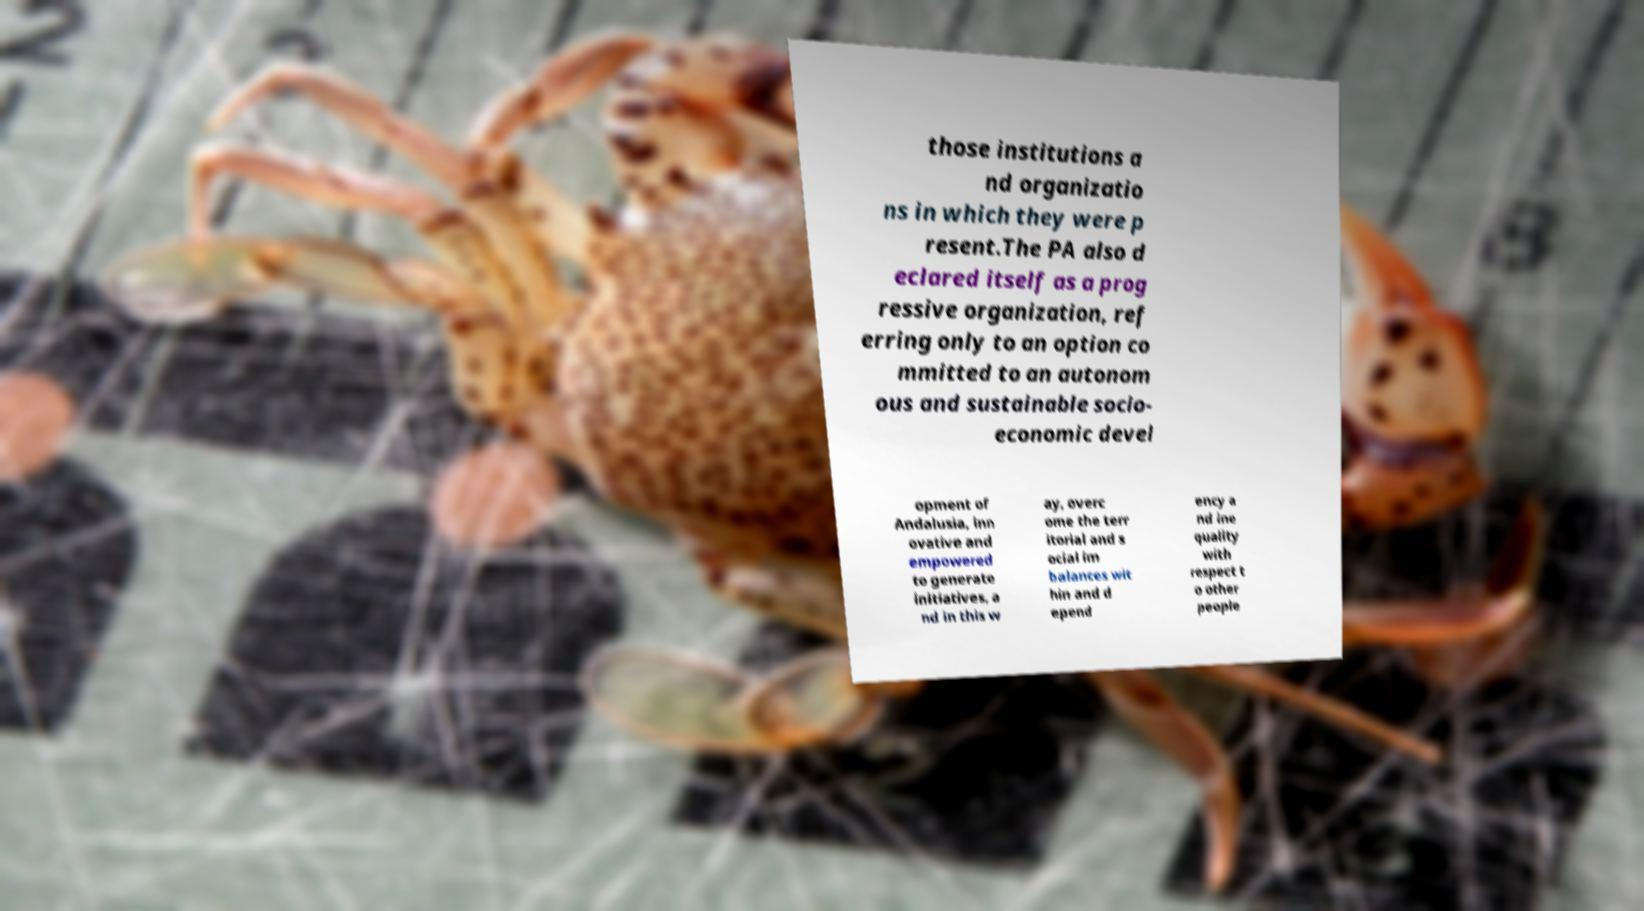For documentation purposes, I need the text within this image transcribed. Could you provide that? those institutions a nd organizatio ns in which they were p resent.The PA also d eclared itself as a prog ressive organization, ref erring only to an option co mmitted to an autonom ous and sustainable socio- economic devel opment of Andalusia, inn ovative and empowered to generate initiatives, a nd in this w ay, overc ome the terr itorial and s ocial im balances wit hin and d epend ency a nd ine quality with respect t o other people 